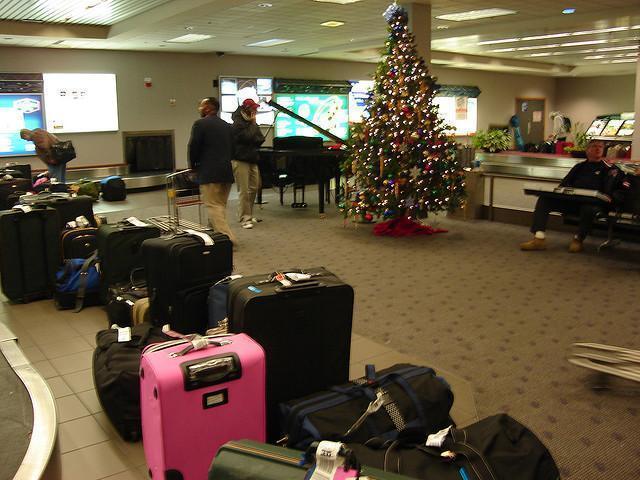A baggage carousel is a device generally at where?
Make your selection from the four choices given to correctly answer the question.
Options: School, hospital, malls, airport. Airport. 